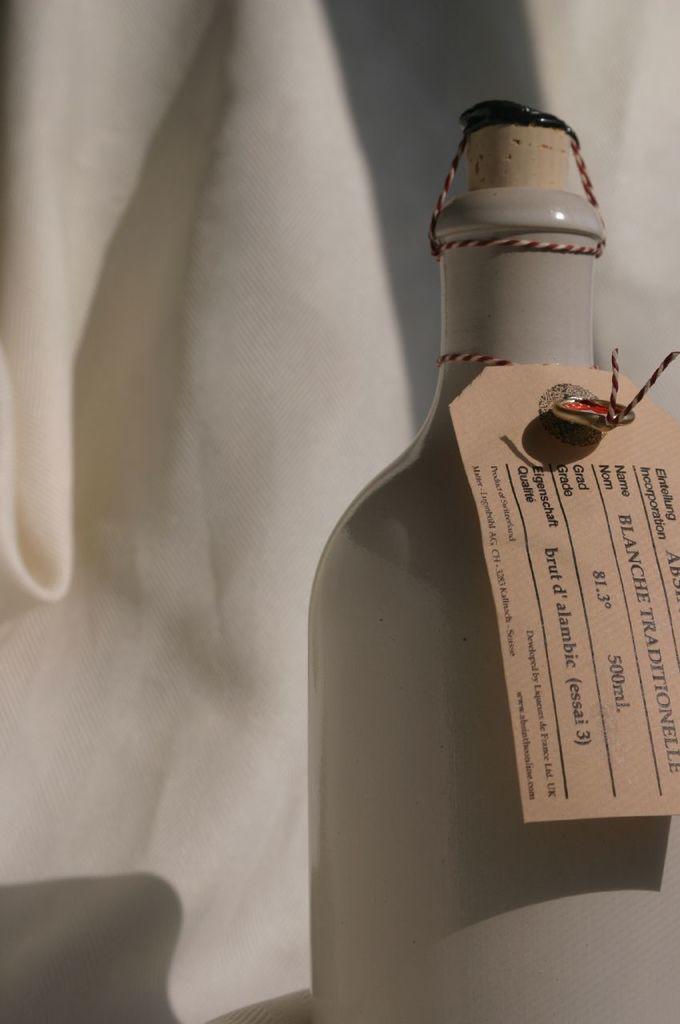What is the name of this beverage?
Keep it short and to the point. Blanche traditionelle. 